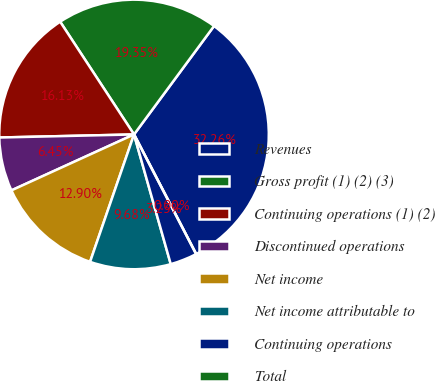Convert chart. <chart><loc_0><loc_0><loc_500><loc_500><pie_chart><fcel>Revenues<fcel>Gross profit (1) (2) (3)<fcel>Continuing operations (1) (2)<fcel>Discontinued operations<fcel>Net income<fcel>Net income attributable to<fcel>Continuing operations<fcel>Total<nl><fcel>32.26%<fcel>19.35%<fcel>16.13%<fcel>6.45%<fcel>12.9%<fcel>9.68%<fcel>3.23%<fcel>0.0%<nl></chart> 